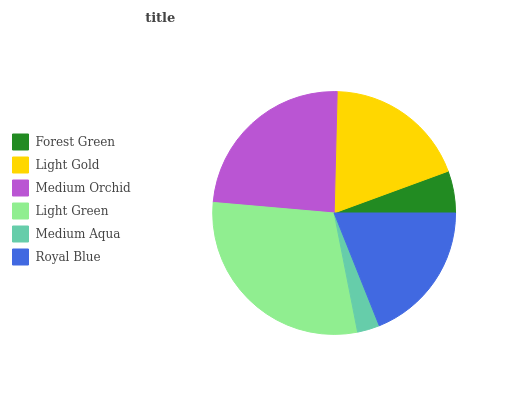Is Medium Aqua the minimum?
Answer yes or no. Yes. Is Light Green the maximum?
Answer yes or no. Yes. Is Light Gold the minimum?
Answer yes or no. No. Is Light Gold the maximum?
Answer yes or no. No. Is Light Gold greater than Forest Green?
Answer yes or no. Yes. Is Forest Green less than Light Gold?
Answer yes or no. Yes. Is Forest Green greater than Light Gold?
Answer yes or no. No. Is Light Gold less than Forest Green?
Answer yes or no. No. Is Light Gold the high median?
Answer yes or no. Yes. Is Royal Blue the low median?
Answer yes or no. Yes. Is Light Green the high median?
Answer yes or no. No. Is Medium Aqua the low median?
Answer yes or no. No. 